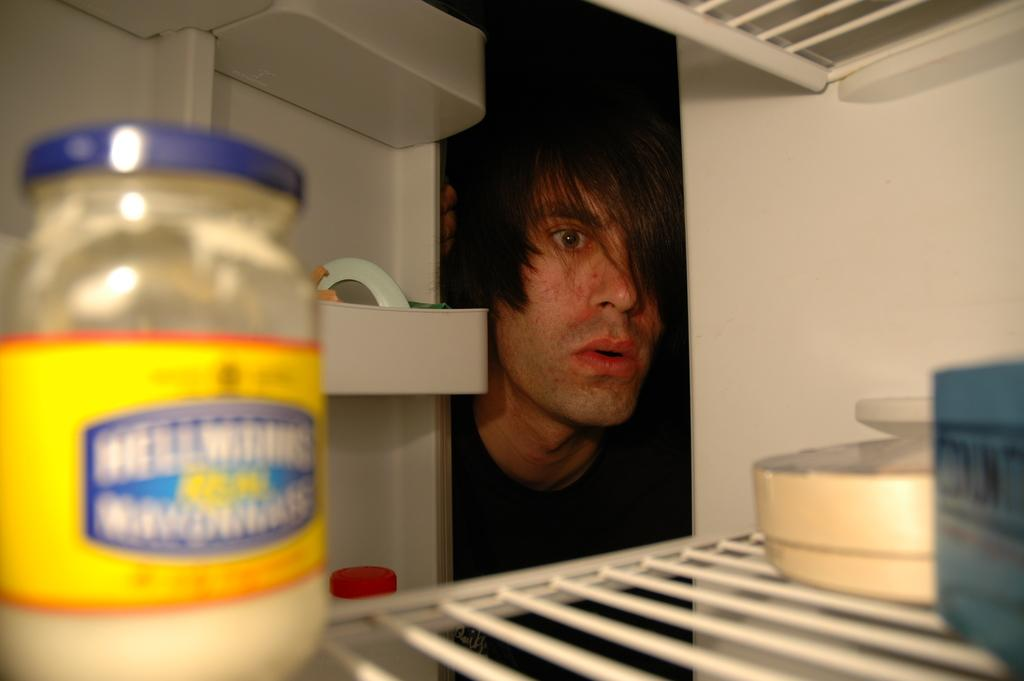Who or what is present in the image? There is a person in the image. What can be seen in the background of the image? There is a shelf in the image. What type of container is visible in the image? There is a tin in the image. Can you describe the objects present in the image? There are objects present in the image, but their specific nature is not mentioned in the provided facts. What type of market can be seen in the background of the image? There is no market present in the image; it only features a person, a shelf, a tin, and unspecified objects. 